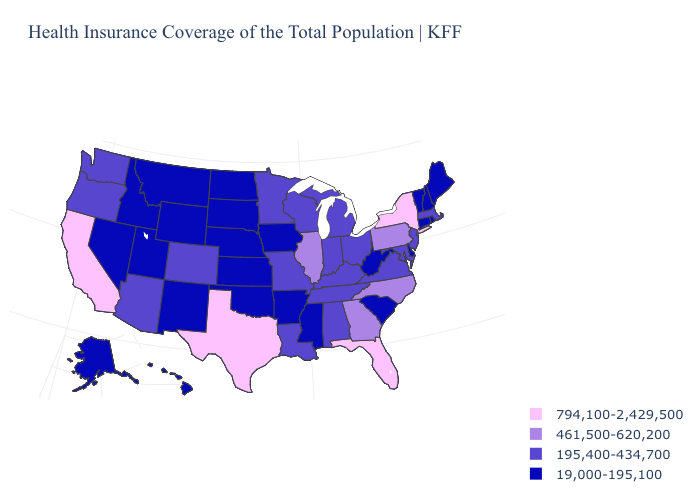Name the states that have a value in the range 195,400-434,700?
Be succinct. Alabama, Arizona, Colorado, Indiana, Kentucky, Louisiana, Maryland, Massachusetts, Michigan, Minnesota, Missouri, New Jersey, Ohio, Oregon, Tennessee, Virginia, Washington, Wisconsin. Name the states that have a value in the range 195,400-434,700?
Keep it brief. Alabama, Arizona, Colorado, Indiana, Kentucky, Louisiana, Maryland, Massachusetts, Michigan, Minnesota, Missouri, New Jersey, Ohio, Oregon, Tennessee, Virginia, Washington, Wisconsin. Name the states that have a value in the range 461,500-620,200?
Give a very brief answer. Georgia, Illinois, North Carolina, Pennsylvania. Does Tennessee have a lower value than North Carolina?
Write a very short answer. Yes. What is the value of Louisiana?
Write a very short answer. 195,400-434,700. Does Alabama have the highest value in the South?
Write a very short answer. No. Name the states that have a value in the range 195,400-434,700?
Short answer required. Alabama, Arizona, Colorado, Indiana, Kentucky, Louisiana, Maryland, Massachusetts, Michigan, Minnesota, Missouri, New Jersey, Ohio, Oregon, Tennessee, Virginia, Washington, Wisconsin. Among the states that border Louisiana , which have the highest value?
Short answer required. Texas. Does North Carolina have the lowest value in the USA?
Give a very brief answer. No. What is the lowest value in states that border Indiana?
Give a very brief answer. 195,400-434,700. What is the value of Nevada?
Concise answer only. 19,000-195,100. Name the states that have a value in the range 461,500-620,200?
Give a very brief answer. Georgia, Illinois, North Carolina, Pennsylvania. What is the value of Mississippi?
Write a very short answer. 19,000-195,100. What is the highest value in the South ?
Quick response, please. 794,100-2,429,500. What is the value of Michigan?
Write a very short answer. 195,400-434,700. 